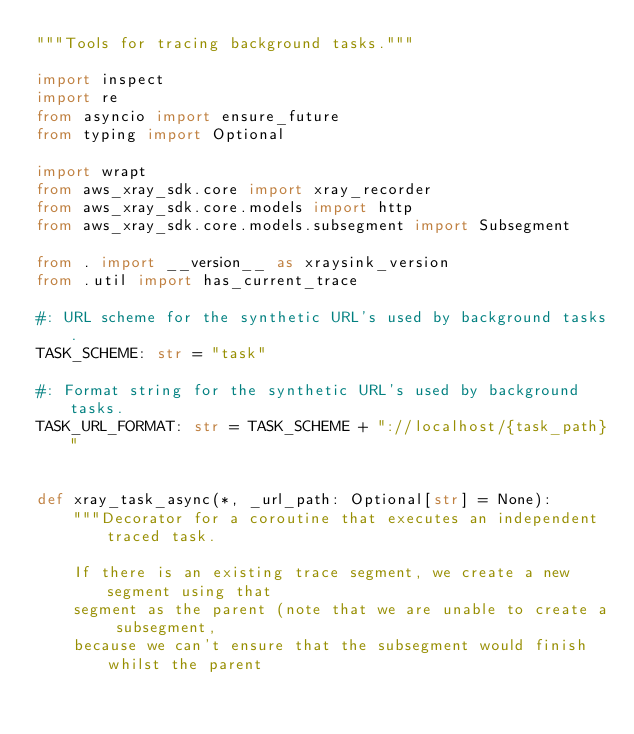<code> <loc_0><loc_0><loc_500><loc_500><_Python_>"""Tools for tracing background tasks."""

import inspect
import re
from asyncio import ensure_future
from typing import Optional

import wrapt
from aws_xray_sdk.core import xray_recorder
from aws_xray_sdk.core.models import http
from aws_xray_sdk.core.models.subsegment import Subsegment

from . import __version__ as xraysink_version
from .util import has_current_trace

#: URL scheme for the synthetic URL's used by background tasks.
TASK_SCHEME: str = "task"

#: Format string for the synthetic URL's used by background tasks.
TASK_URL_FORMAT: str = TASK_SCHEME + "://localhost/{task_path}"


def xray_task_async(*, _url_path: Optional[str] = None):
    """Decorator for a coroutine that executes an independent traced task.

    If there is an existing trace segment, we create a new segment using that
    segment as the parent (note that we are unable to create a subsegment,
    because we can't ensure that the subsegment would finish whilst the parent</code> 